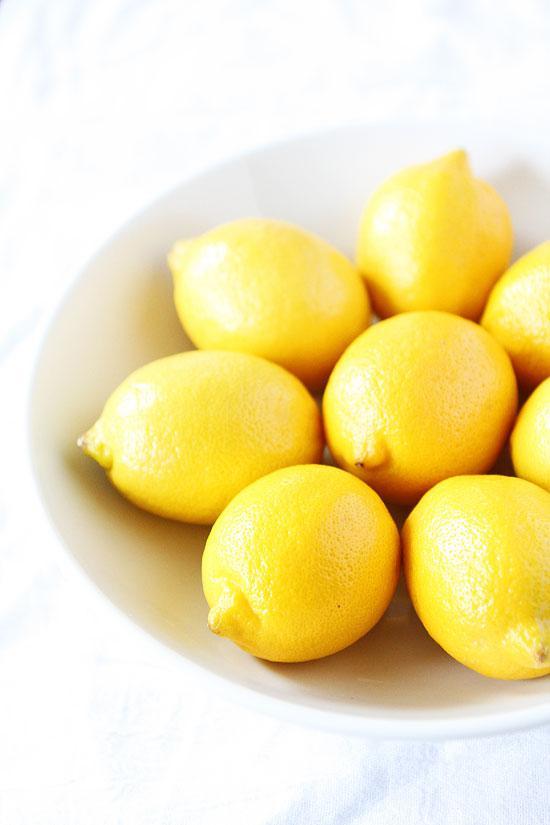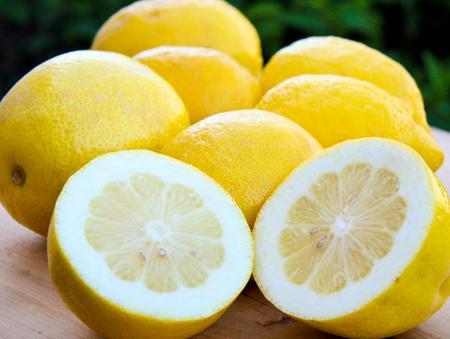The first image is the image on the left, the second image is the image on the right. Considering the images on both sides, is "One image contains exactly two intact lemons, and the other includes a lemon half." valid? Answer yes or no. No. The first image is the image on the left, the second image is the image on the right. Examine the images to the left and right. Is the description "The left image contains exactly two uncut lemons." accurate? Answer yes or no. No. 